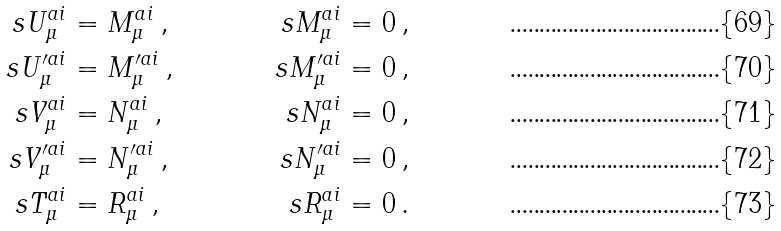Convert formula to latex. <formula><loc_0><loc_0><loc_500><loc_500>s U _ { \mu } ^ { a i } & = M _ { \mu } ^ { a i } \, , & s M _ { \mu } ^ { a i } & = 0 \, , \\ s U _ { \mu } ^ { \prime a i } & = M _ { \mu } ^ { \prime a i } \, , & s M _ { \mu } ^ { \prime a i } & = 0 \, , \\ s V _ { \mu } ^ { a i } & = N _ { \mu } ^ { a i } \, , & s N _ { \mu } ^ { a i } & = 0 \, , \\ s V _ { \mu } ^ { \prime a i } & = N _ { \mu } ^ { \prime a i } \, , & s N _ { \mu } ^ { \prime a i } & = 0 \, , \\ s T _ { \mu } ^ { a i } & = R _ { \mu } ^ { a i } \, , & s R _ { \mu } ^ { a i } & = 0 \, .</formula> 